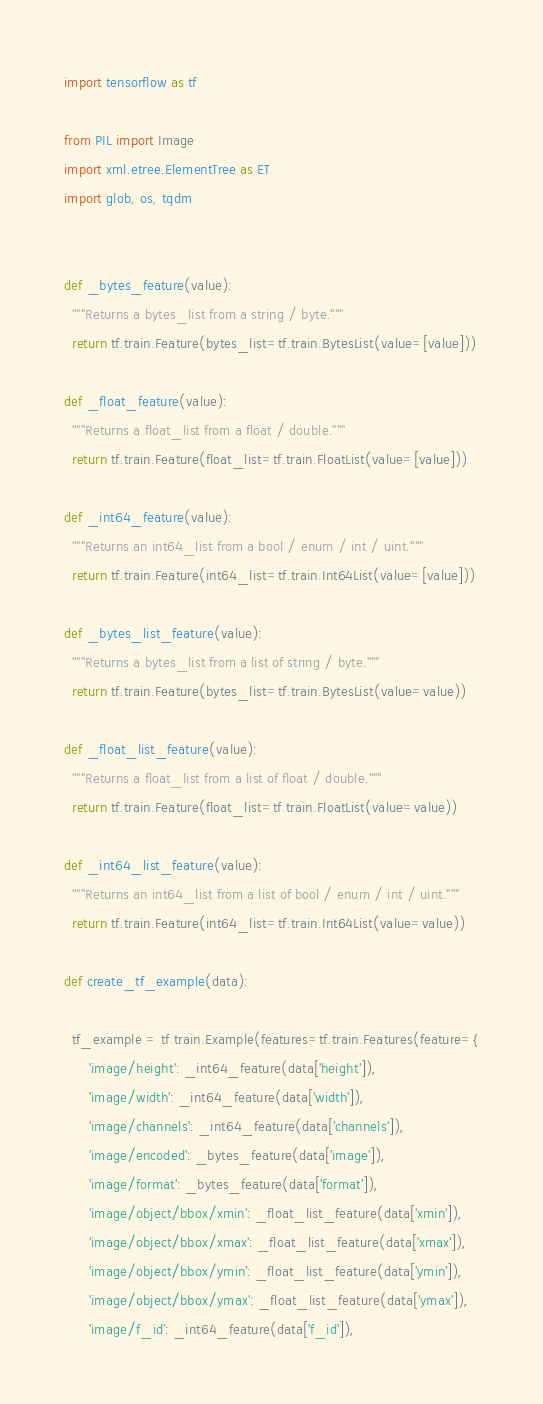<code> <loc_0><loc_0><loc_500><loc_500><_Python_>import tensorflow as tf

from PIL import Image
import xml.etree.ElementTree as ET
import glob, os, tqdm


def _bytes_feature(value):
  """Returns a bytes_list from a string / byte."""
  return tf.train.Feature(bytes_list=tf.train.BytesList(value=[value]))

def _float_feature(value):
  """Returns a float_list from a float / double."""
  return tf.train.Feature(float_list=tf.train.FloatList(value=[value]))

def _int64_feature(value):
  """Returns an int64_list from a bool / enum / int / uint."""
  return tf.train.Feature(int64_list=tf.train.Int64List(value=[value]))

def _bytes_list_feature(value):
  """Returns a bytes_list from a list of string / byte."""
  return tf.train.Feature(bytes_list=tf.train.BytesList(value=value))

def _float_list_feature(value):
  """Returns a float_list from a list of float / double."""
  return tf.train.Feature(float_list=tf.train.FloatList(value=value))

def _int64_list_feature(value):
  """Returns an int64_list from a list of bool / enum / int / uint."""
  return tf.train.Feature(int64_list=tf.train.Int64List(value=value))

def create_tf_example(data):

  tf_example = tf.train.Example(features=tf.train.Features(feature={
      'image/height': _int64_feature(data['height']),
      'image/width': _int64_feature(data['width']),
      'image/channels': _int64_feature(data['channels']),
      'image/encoded': _bytes_feature(data['image']),
      'image/format': _bytes_feature(data['format']),
      'image/object/bbox/xmin': _float_list_feature(data['xmin']),
      'image/object/bbox/xmax': _float_list_feature(data['xmax']),
      'image/object/bbox/ymin': _float_list_feature(data['ymin']),
      'image/object/bbox/ymax': _float_list_feature(data['ymax']),
      'image/f_id': _int64_feature(data['f_id']),</code> 